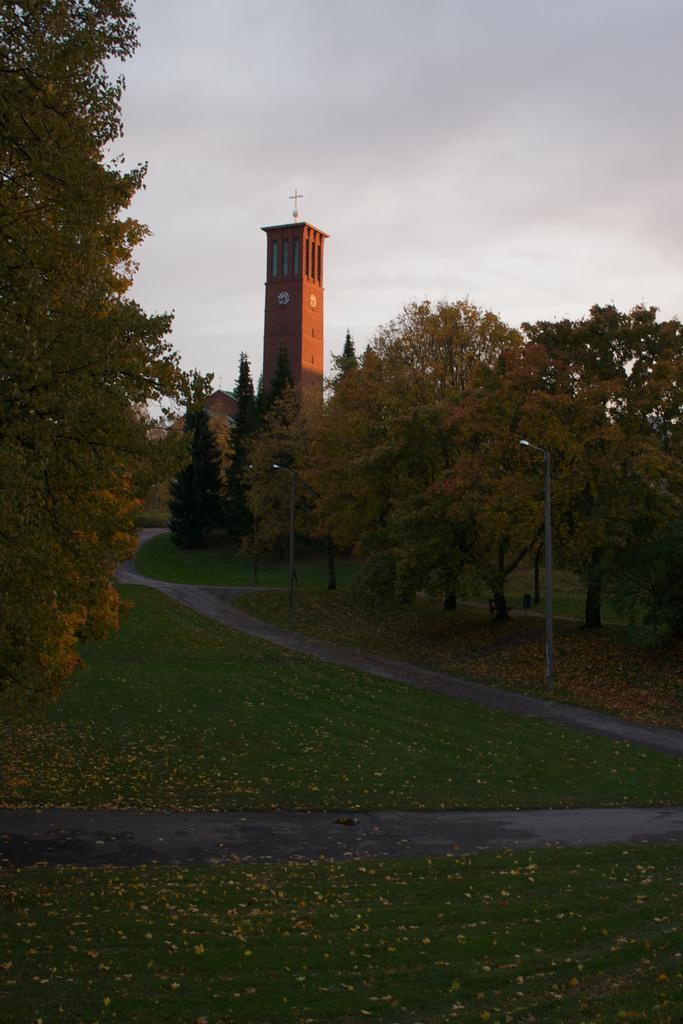In one or two sentences, can you explain what this image depicts? In the background we can see the sky and a tower. We can see the clocks and a cross symbol. In this picture we can see the trees, grass, light poles, pathway and few objects. 